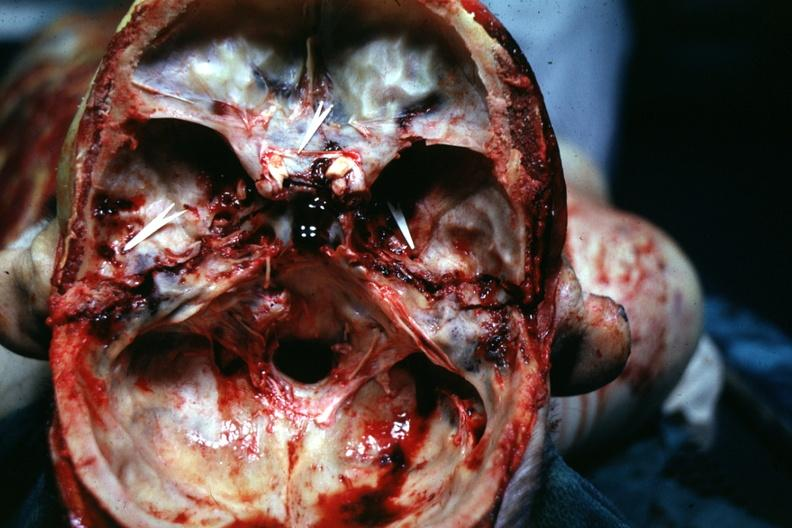s tumor present?
Answer the question using a single word or phrase. No 